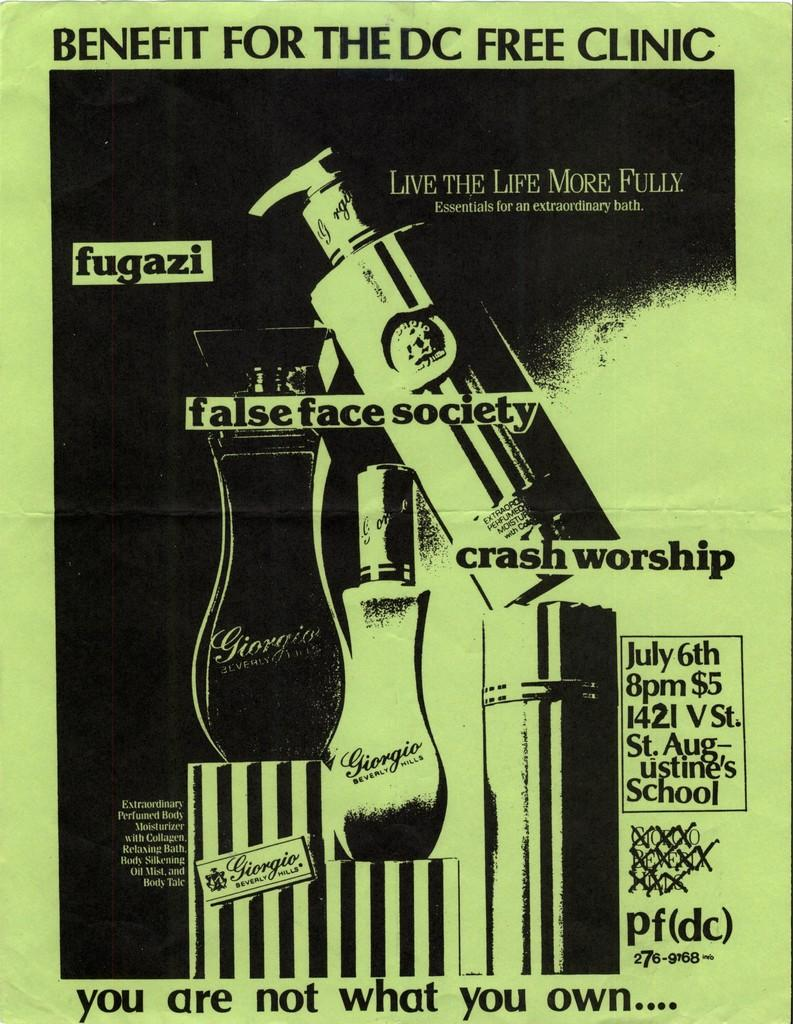What objects are present in the image? There are bottles in the image. What feature do the bottles have? The bottles have text on them. What colors are used for the text on the bottles? The text is in black and white color. Can you tell me how many kites are being sold in the shop in the image? There is no shop or kites present in the image; it only features bottles with text on them. How many brothers are visible in the image? There are no people, including brothers, present in the image. 